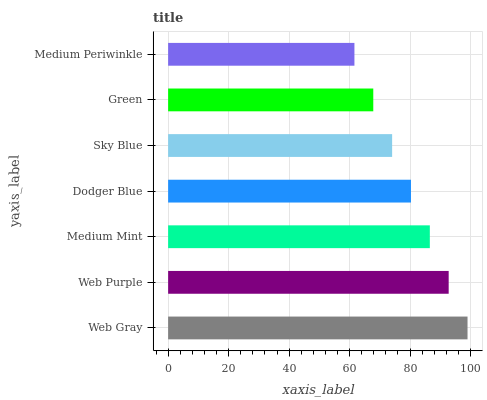Is Medium Periwinkle the minimum?
Answer yes or no. Yes. Is Web Gray the maximum?
Answer yes or no. Yes. Is Web Purple the minimum?
Answer yes or no. No. Is Web Purple the maximum?
Answer yes or no. No. Is Web Gray greater than Web Purple?
Answer yes or no. Yes. Is Web Purple less than Web Gray?
Answer yes or no. Yes. Is Web Purple greater than Web Gray?
Answer yes or no. No. Is Web Gray less than Web Purple?
Answer yes or no. No. Is Dodger Blue the high median?
Answer yes or no. Yes. Is Dodger Blue the low median?
Answer yes or no. Yes. Is Sky Blue the high median?
Answer yes or no. No. Is Green the low median?
Answer yes or no. No. 